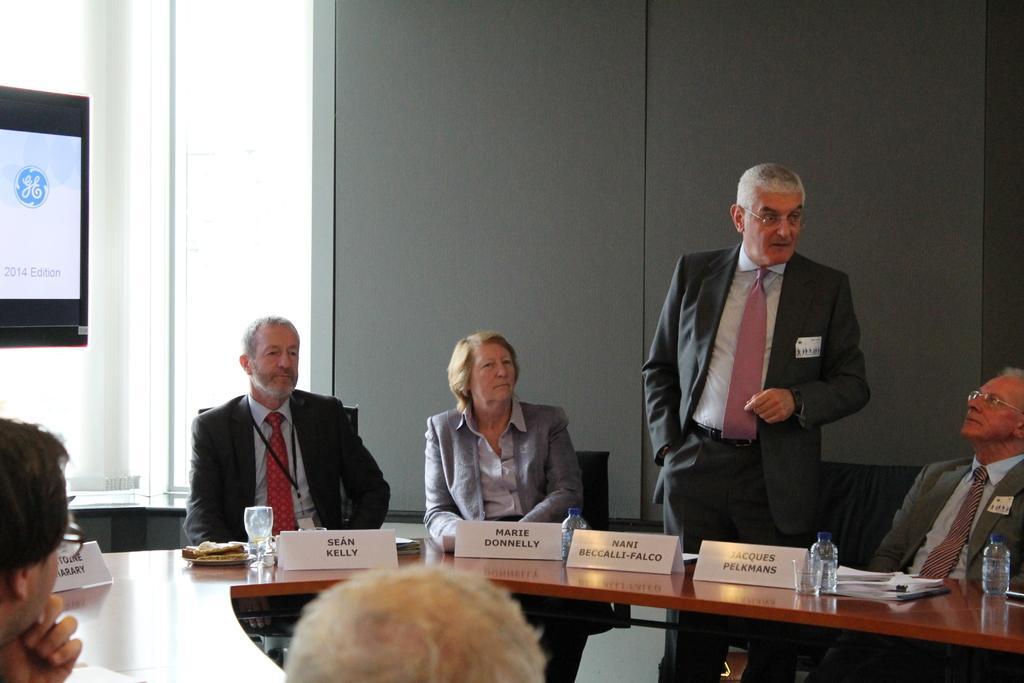In one or two sentences, can you explain what this image depicts? In this picture we can observe some members sitting around the conference table. There are glasses, water bottles and name boards on the table. There were men and a woman. On the left side we can observe a screen. In the background there is a wall. 